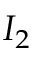Convert formula to latex. <formula><loc_0><loc_0><loc_500><loc_500>I _ { 2 }</formula> 